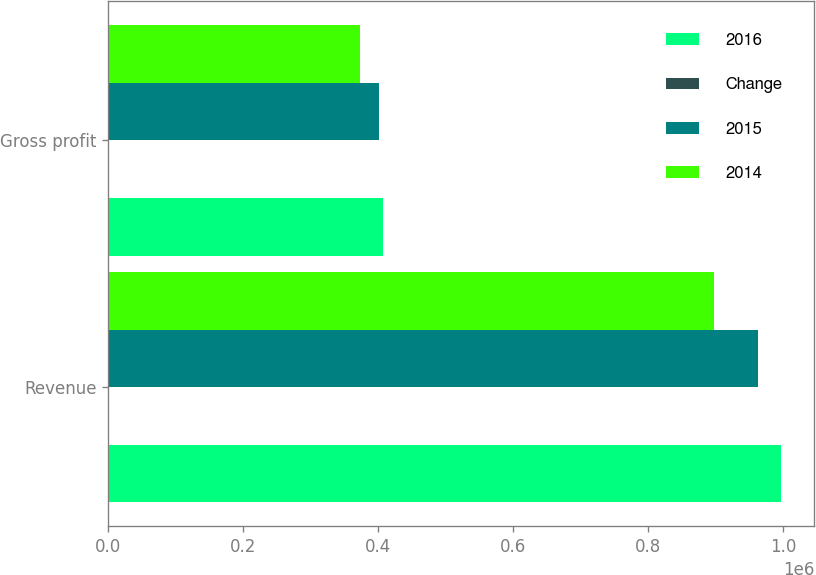Convert chart to OTSL. <chart><loc_0><loc_0><loc_500><loc_500><stacked_bar_chart><ecel><fcel>Revenue<fcel>Gross profit<nl><fcel>2016<fcel>996668<fcel>407600<nl><fcel>Change<fcel>4<fcel>2<nl><fcel>2015<fcel>962729<fcel>400659<nl><fcel>2014<fcel>897671<fcel>372473<nl></chart> 